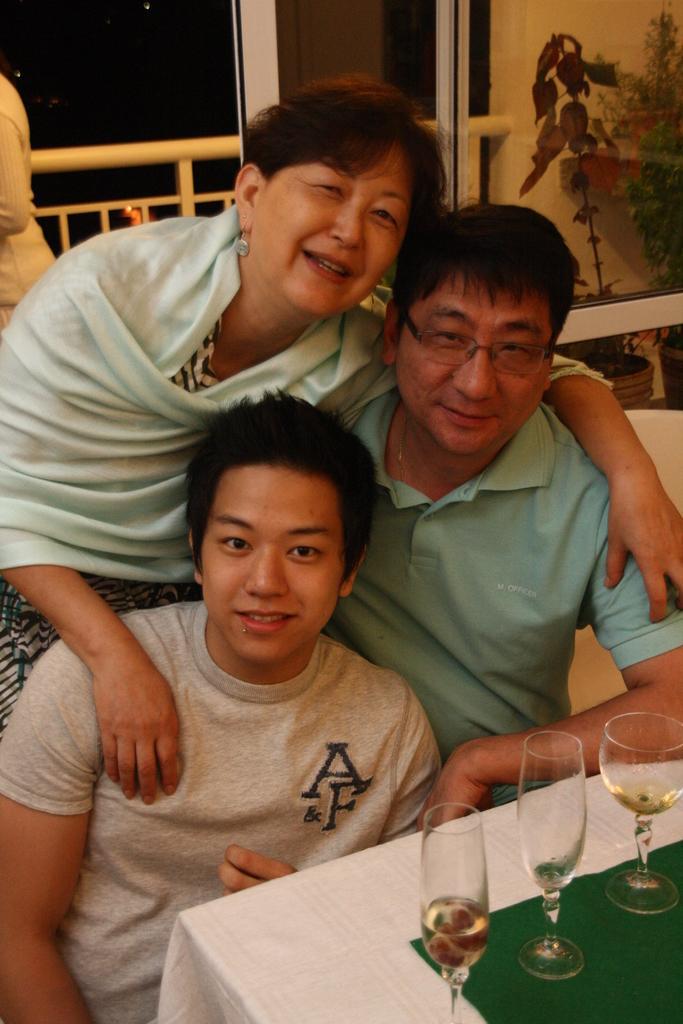How would you summarize this image in a sentence or two? Here we can see a group of persons, and in front here is the table and wine glass on it, and at back here is the glass door, and here is the flower pot. 